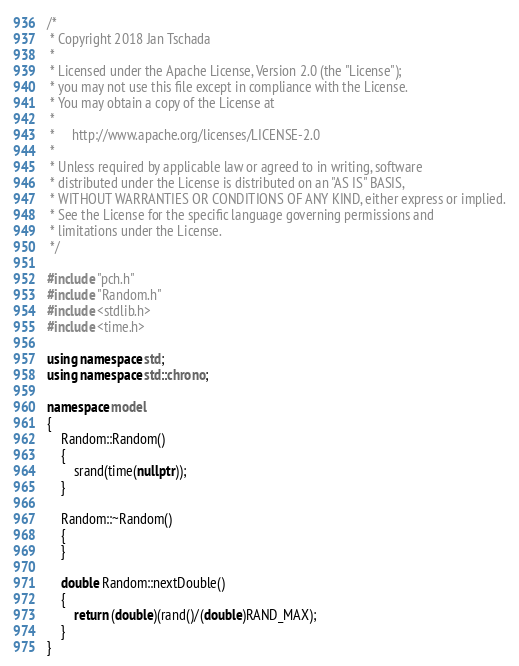<code> <loc_0><loc_0><loc_500><loc_500><_C++_>/*
 * Copyright 2018 Jan Tschada
 *
 * Licensed under the Apache License, Version 2.0 (the "License");
 * you may not use this file except in compliance with the License.
 * You may obtain a copy of the License at
 *
 *     http://www.apache.org/licenses/LICENSE-2.0
 *
 * Unless required by applicable law or agreed to in writing, software
 * distributed under the License is distributed on an "AS IS" BASIS,
 * WITHOUT WARRANTIES OR CONDITIONS OF ANY KIND, either express or implied.
 * See the License for the specific language governing permissions and
 * limitations under the License.
 */

#include "pch.h"
#include "Random.h"
#include <stdlib.h>
#include <time.h>

using namespace std;
using namespace std::chrono;

namespace model
{
	Random::Random()
	{
		srand(time(nullptr));
	}

	Random::~Random()
	{
	}

	double Random::nextDouble()
	{
		return (double)(rand()/(double)RAND_MAX);
	}
}</code> 